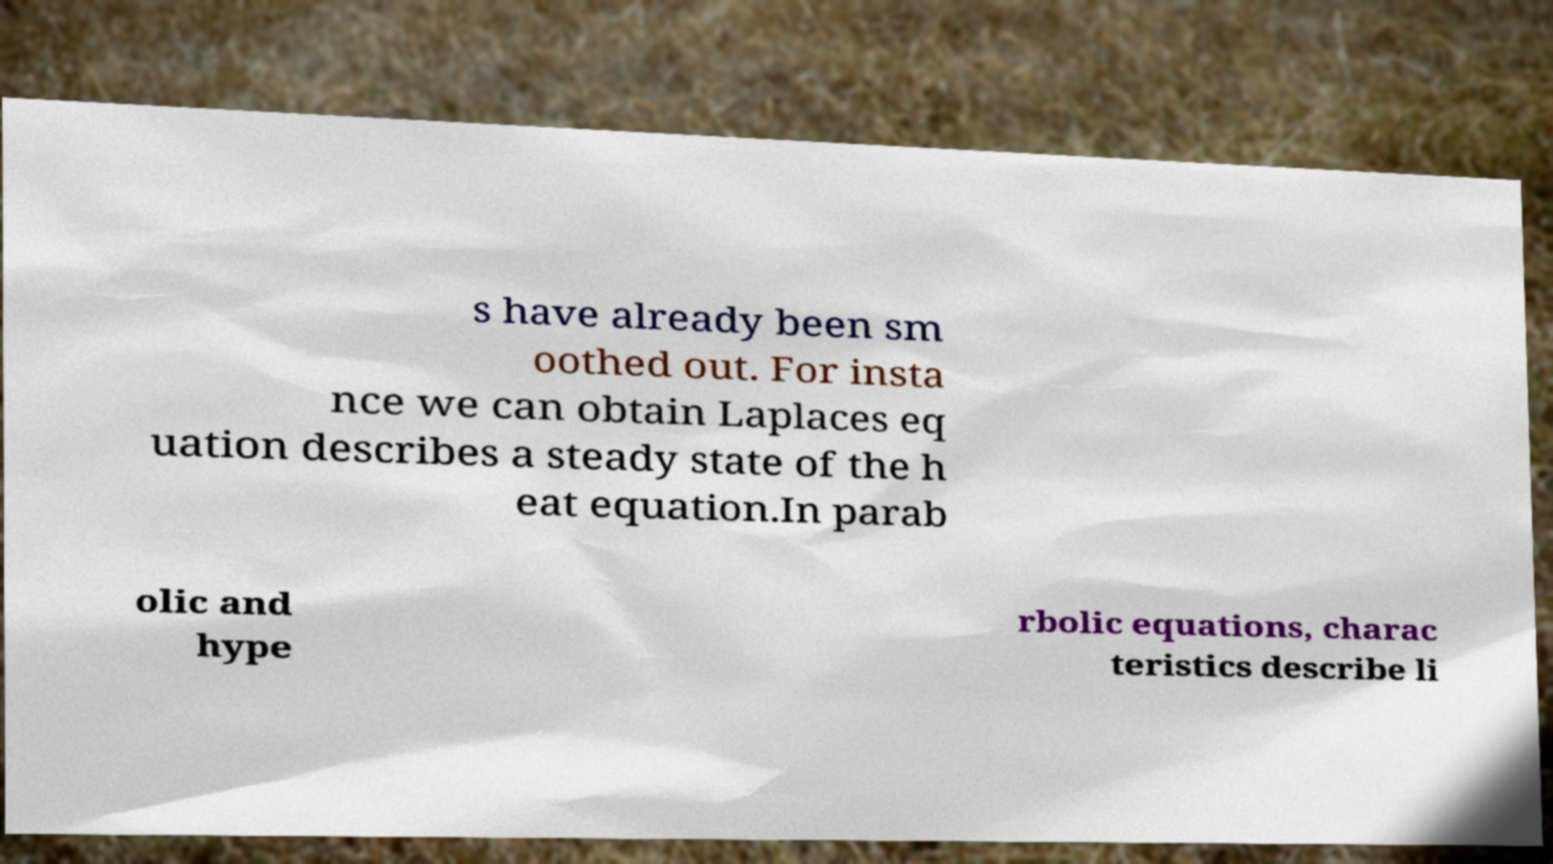Could you assist in decoding the text presented in this image and type it out clearly? s have already been sm oothed out. For insta nce we can obtain Laplaces eq uation describes a steady state of the h eat equation.In parab olic and hype rbolic equations, charac teristics describe li 